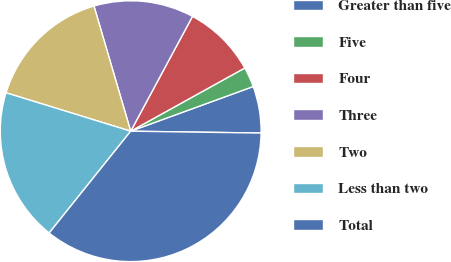Convert chart to OTSL. <chart><loc_0><loc_0><loc_500><loc_500><pie_chart><fcel>Greater than five<fcel>Five<fcel>Four<fcel>Three<fcel>Two<fcel>Less than two<fcel>Total<nl><fcel>5.79%<fcel>2.49%<fcel>9.09%<fcel>12.4%<fcel>15.7%<fcel>19.01%<fcel>35.52%<nl></chart> 